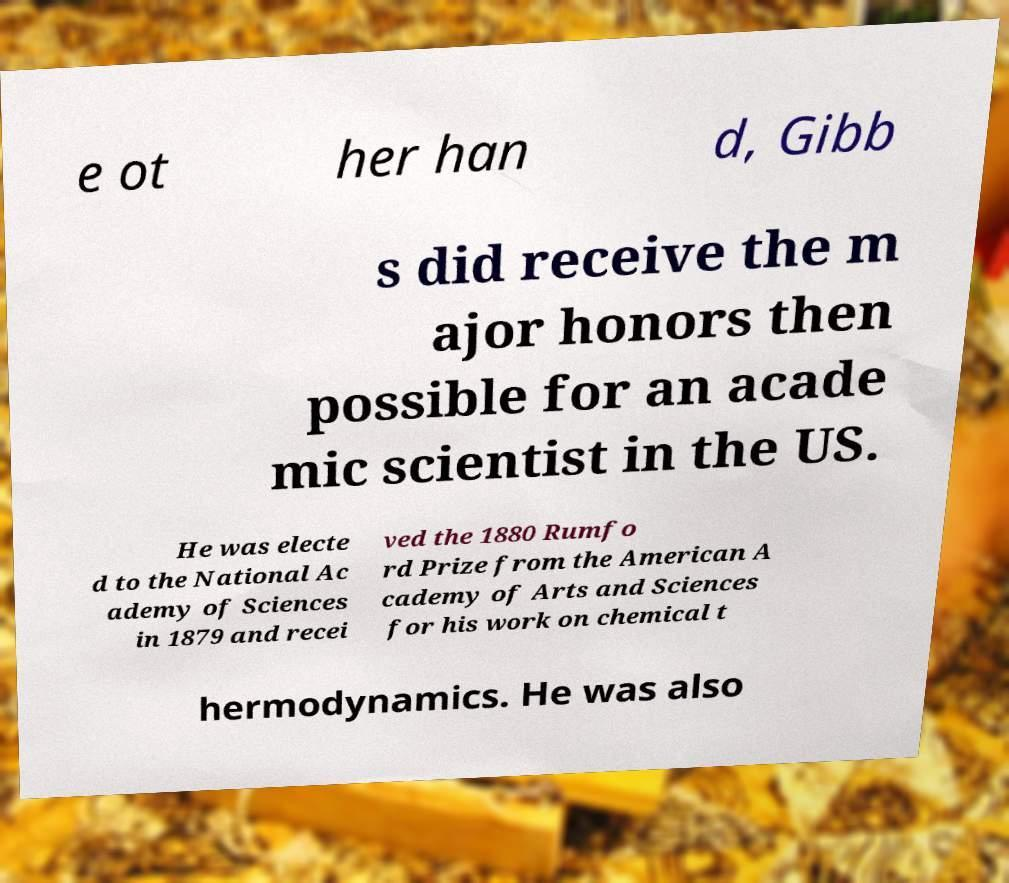Please read and relay the text visible in this image. What does it say? e ot her han d, Gibb s did receive the m ajor honors then possible for an acade mic scientist in the US. He was electe d to the National Ac ademy of Sciences in 1879 and recei ved the 1880 Rumfo rd Prize from the American A cademy of Arts and Sciences for his work on chemical t hermodynamics. He was also 